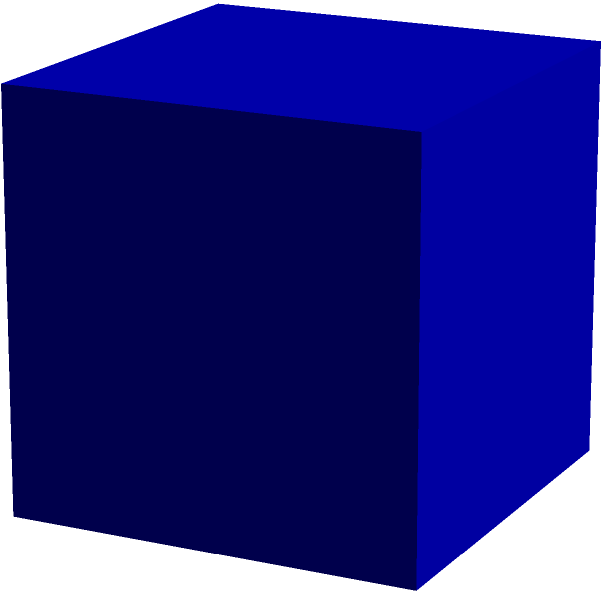As a scientist familiar with three-dimensional visualization, analyze the given image. It shows a 3D shape (in blue) along with its 2D projections from different angles (in red, green, and yellow). Based on these projections, what is the most likely 3D shape represented? To determine the 3D shape, let's analyze the projections step-by-step:

1. Front projection (red):
   - Shows a square shape
   - Indicates that the front face of the 3D object is square

2. Side projection (green):
   - Also shows a square shape
   - Suggests that the side face of the 3D object is also square

3. Top projection (yellow):
   - Again shows a square shape
   - Implies that the top face of the 3D object is square as well

4. Consistency of projections:
   - All three projections (front, side, and top) show squares of the same size
   - This consistency suggests that all faces of the 3D object are identical squares

5. Properties of a cube:
   - A cube is defined as a 3D shape with six identical square faces
   - All edges of a cube are equal in length
   - All face diagonals of a cube are equal

6. Matching observations with properties:
   - The given projections show square faces from all three principal directions
   - This is consistent with the properties of a cube

Therefore, based on the 2D projections provided and the analysis of their consistency, the most likely 3D shape represented is a cube.
Answer: Cube 